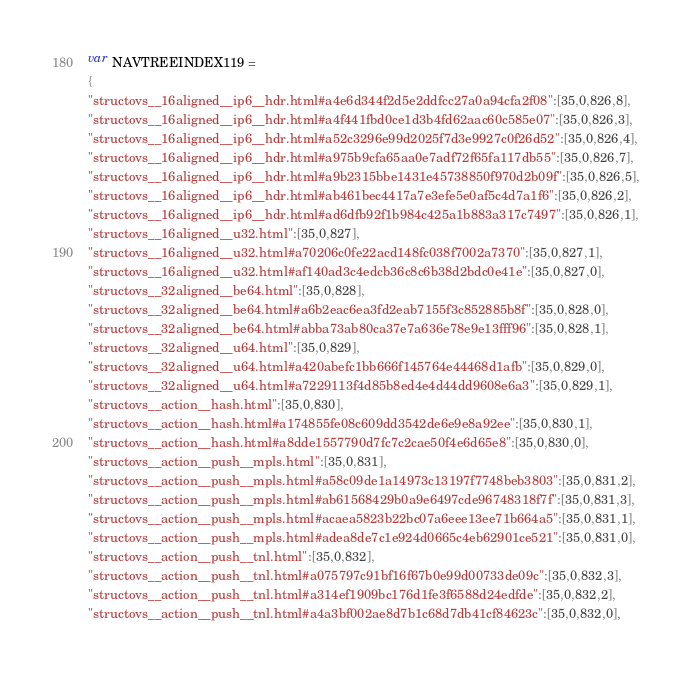<code> <loc_0><loc_0><loc_500><loc_500><_JavaScript_>var NAVTREEINDEX119 =
{
"structovs__16aligned__ip6__hdr.html#a4e6d344f2d5e2ddfcc27a0a94cfa2f08":[35,0,826,8],
"structovs__16aligned__ip6__hdr.html#a4f441fbd0ce1d3b4fd62aac60c585e07":[35,0,826,3],
"structovs__16aligned__ip6__hdr.html#a52c3296e99d2025f7d3e9927c0f26d52":[35,0,826,4],
"structovs__16aligned__ip6__hdr.html#a975b9cfa65aa0e7adf72f65fa117db55":[35,0,826,7],
"structovs__16aligned__ip6__hdr.html#a9b2315bbe1431e45738850f970d2b09f":[35,0,826,5],
"structovs__16aligned__ip6__hdr.html#ab461bec4417a7e3efe5e0af5c4d7a1f6":[35,0,826,2],
"structovs__16aligned__ip6__hdr.html#ad6dfb92f1b984c425a1b883a317c7497":[35,0,826,1],
"structovs__16aligned__u32.html":[35,0,827],
"structovs__16aligned__u32.html#a70206c0fe22acd148fc038f7002a7370":[35,0,827,1],
"structovs__16aligned__u32.html#af140ad3c4edcb36c8c6b38d2bdc0e41e":[35,0,827,0],
"structovs__32aligned__be64.html":[35,0,828],
"structovs__32aligned__be64.html#a6b2eac6ea3fd2eab7155f3c852885b8f":[35,0,828,0],
"structovs__32aligned__be64.html#abba73ab80ca37e7a636e78e9e13fff96":[35,0,828,1],
"structovs__32aligned__u64.html":[35,0,829],
"structovs__32aligned__u64.html#a420abefc1bb666f145764e44468d1afb":[35,0,829,0],
"structovs__32aligned__u64.html#a7229113f4d85b8ed4e4d44dd9608e6a3":[35,0,829,1],
"structovs__action__hash.html":[35,0,830],
"structovs__action__hash.html#a174855fe08c609dd3542de6e9e8a92ee":[35,0,830,1],
"structovs__action__hash.html#a8dde1557790d7fc7c2cae50f4e6d65e8":[35,0,830,0],
"structovs__action__push__mpls.html":[35,0,831],
"structovs__action__push__mpls.html#a58c09de1a14973c13197f7748beb3803":[35,0,831,2],
"structovs__action__push__mpls.html#ab61568429b0a9e6497cde96748318f7f":[35,0,831,3],
"structovs__action__push__mpls.html#acaea5823b22bc07a6eee13ee71b664a5":[35,0,831,1],
"structovs__action__push__mpls.html#adea8de7c1e924d0665c4eb62901ce521":[35,0,831,0],
"structovs__action__push__tnl.html":[35,0,832],
"structovs__action__push__tnl.html#a075797c91bf16f67b0e99d00733de09c":[35,0,832,3],
"structovs__action__push__tnl.html#a314ef1909bc176d1fe3f6588d24edfde":[35,0,832,2],
"structovs__action__push__tnl.html#a4a3bf002ae8d7b1c68d7db41cf84623c":[35,0,832,0],</code> 